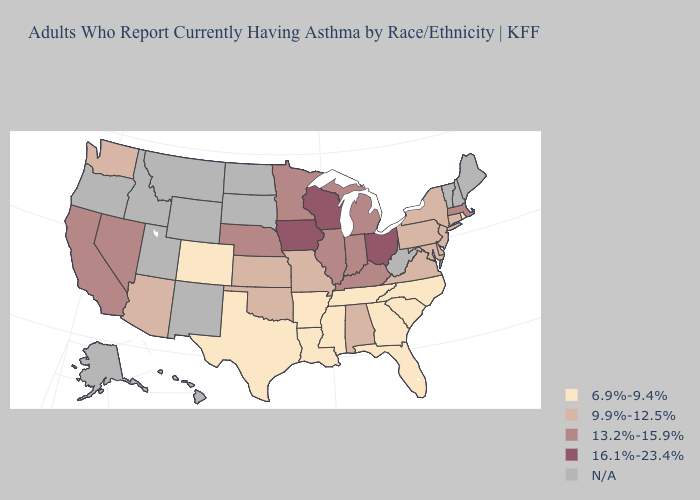Does the first symbol in the legend represent the smallest category?
Answer briefly. Yes. Name the states that have a value in the range 13.2%-15.9%?
Answer briefly. California, Illinois, Indiana, Kentucky, Massachusetts, Michigan, Minnesota, Nebraska, Nevada. What is the value of Illinois?
Quick response, please. 13.2%-15.9%. How many symbols are there in the legend?
Concise answer only. 5. Name the states that have a value in the range N/A?
Give a very brief answer. Alaska, Hawaii, Idaho, Maine, Montana, New Hampshire, New Mexico, North Dakota, Oregon, South Dakota, Utah, Vermont, West Virginia, Wyoming. What is the highest value in the USA?
Write a very short answer. 16.1%-23.4%. What is the value of Missouri?
Short answer required. 9.9%-12.5%. Name the states that have a value in the range 6.9%-9.4%?
Give a very brief answer. Arkansas, Colorado, Florida, Georgia, Louisiana, Mississippi, North Carolina, Rhode Island, South Carolina, Tennessee, Texas. Does the first symbol in the legend represent the smallest category?
Write a very short answer. Yes. Which states hav the highest value in the West?
Answer briefly. California, Nevada. What is the value of Delaware?
Short answer required. 9.9%-12.5%. Does the first symbol in the legend represent the smallest category?
Be succinct. Yes. Which states have the highest value in the USA?
Short answer required. Iowa, Ohio, Wisconsin. 